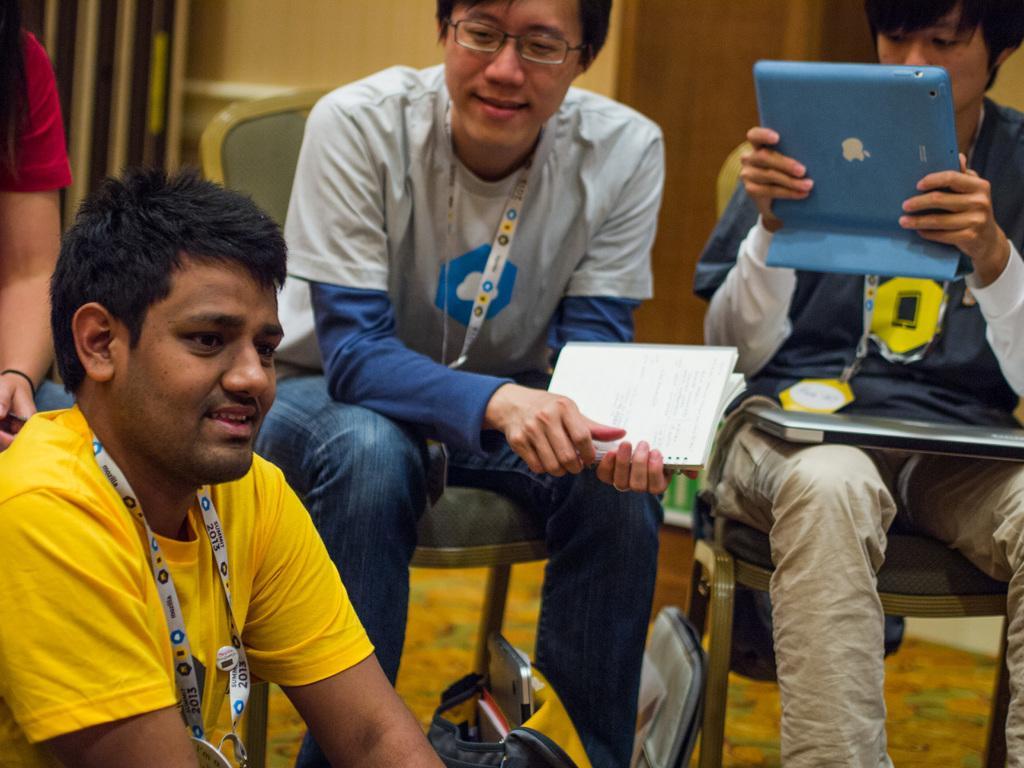Can you describe this image briefly? There are three people sitting. This man is holding a book in his hands. At the bottom of the image, I can see a bag with few things in it. On the left side of the image, I can see another person. This person is holding a tablet in his hands. I think this is a laptop. In the background, I think this is a wooden door. 